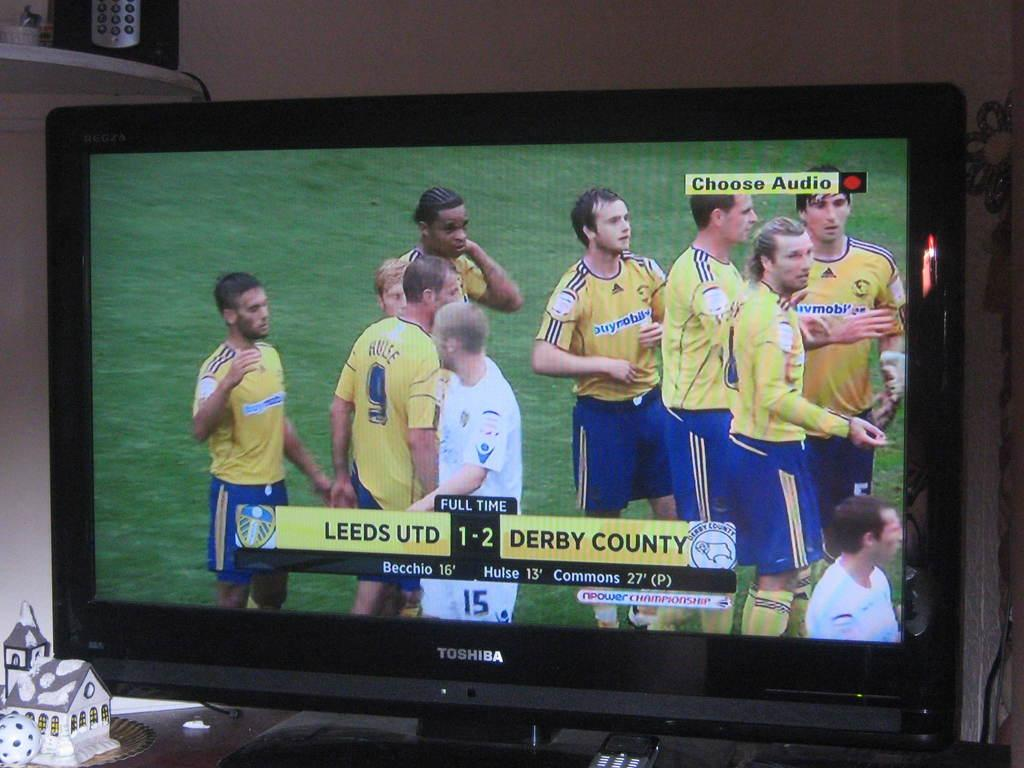Provide a one-sentence caption for the provided image. A TV showing the game Leeds UTD vs. Derby County with a score of 1-2. 